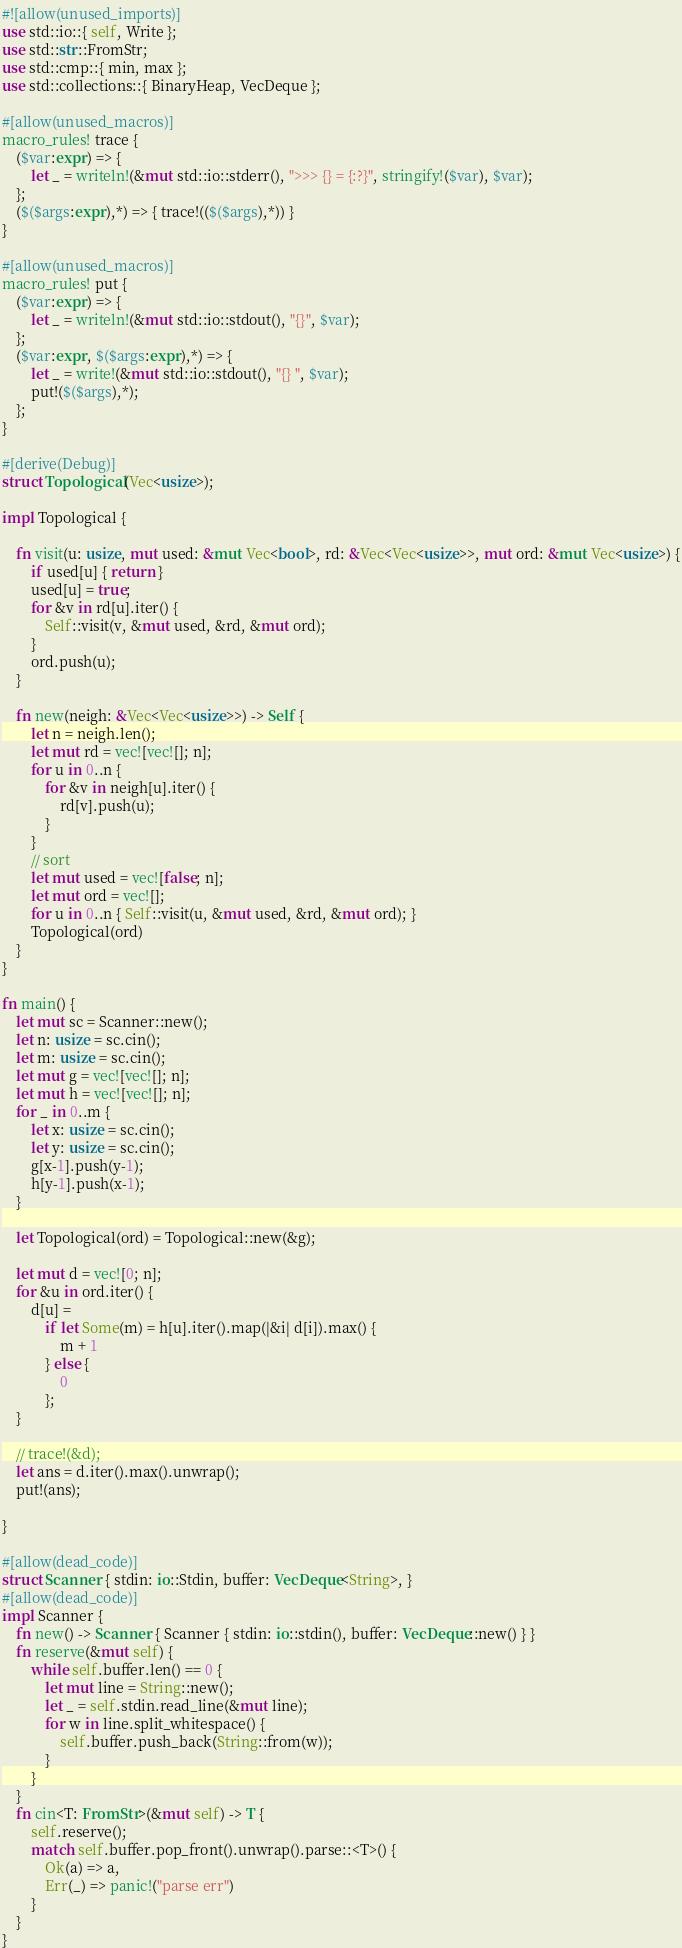<code> <loc_0><loc_0><loc_500><loc_500><_Rust_>#![allow(unused_imports)]
use std::io::{ self, Write };
use std::str::FromStr;
use std::cmp::{ min, max };
use std::collections::{ BinaryHeap, VecDeque };

#[allow(unused_macros)]
macro_rules! trace {
    ($var:expr) => {
        let _ = writeln!(&mut std::io::stderr(), ">>> {} = {:?}", stringify!($var), $var);
    };
    ($($args:expr),*) => { trace!(($($args),*)) }
}

#[allow(unused_macros)]
macro_rules! put {
    ($var:expr) => {
        let _ = writeln!(&mut std::io::stdout(), "{}", $var);
    };
    ($var:expr, $($args:expr),*) => {
        let _ = write!(&mut std::io::stdout(), "{} ", $var);
        put!($($args),*);
    };
}

#[derive(Debug)]
struct Topological(Vec<usize>);

impl Topological {

    fn visit(u: usize, mut used: &mut Vec<bool>, rd: &Vec<Vec<usize>>, mut ord: &mut Vec<usize>) {
        if used[u] { return }
        used[u] = true;
        for &v in rd[u].iter() {
            Self::visit(v, &mut used, &rd, &mut ord);
        }
        ord.push(u);
    }

    fn new(neigh: &Vec<Vec<usize>>) -> Self {
        let n = neigh.len();
        let mut rd = vec![vec![]; n];
        for u in 0..n {
            for &v in neigh[u].iter() {
                rd[v].push(u);
            }
        }
        // sort
        let mut used = vec![false; n];
        let mut ord = vec![];
        for u in 0..n { Self::visit(u, &mut used, &rd, &mut ord); }
        Topological(ord)
    }
}

fn main() {
    let mut sc = Scanner::new();
    let n: usize = sc.cin();
    let m: usize = sc.cin();
    let mut g = vec![vec![]; n];
    let mut h = vec![vec![]; n];
    for _ in 0..m {
        let x: usize = sc.cin();
        let y: usize = sc.cin();
        g[x-1].push(y-1);
        h[y-1].push(x-1);
    }

    let Topological(ord) = Topological::new(&g);

    let mut d = vec![0; n];
    for &u in ord.iter() {
        d[u] =
            if let Some(m) = h[u].iter().map(|&i| d[i]).max() {
                m + 1
            } else {
                0
            };
    }

    // trace!(&d);
    let ans = d.iter().max().unwrap();
    put!(ans);

}

#[allow(dead_code)]
struct Scanner { stdin: io::Stdin, buffer: VecDeque<String>, }
#[allow(dead_code)]
impl Scanner {
    fn new() -> Scanner { Scanner { stdin: io::stdin(), buffer: VecDeque::new() } }
    fn reserve(&mut self) {
        while self.buffer.len() == 0 {
            let mut line = String::new();
            let _ = self.stdin.read_line(&mut line);
            for w in line.split_whitespace() {
                self.buffer.push_back(String::from(w));
            }
        }
    }
    fn cin<T: FromStr>(&mut self) -> T {
        self.reserve();
        match self.buffer.pop_front().unwrap().parse::<T>() {
            Ok(a) => a,
            Err(_) => panic!("parse err")
        }
    }
}
</code> 